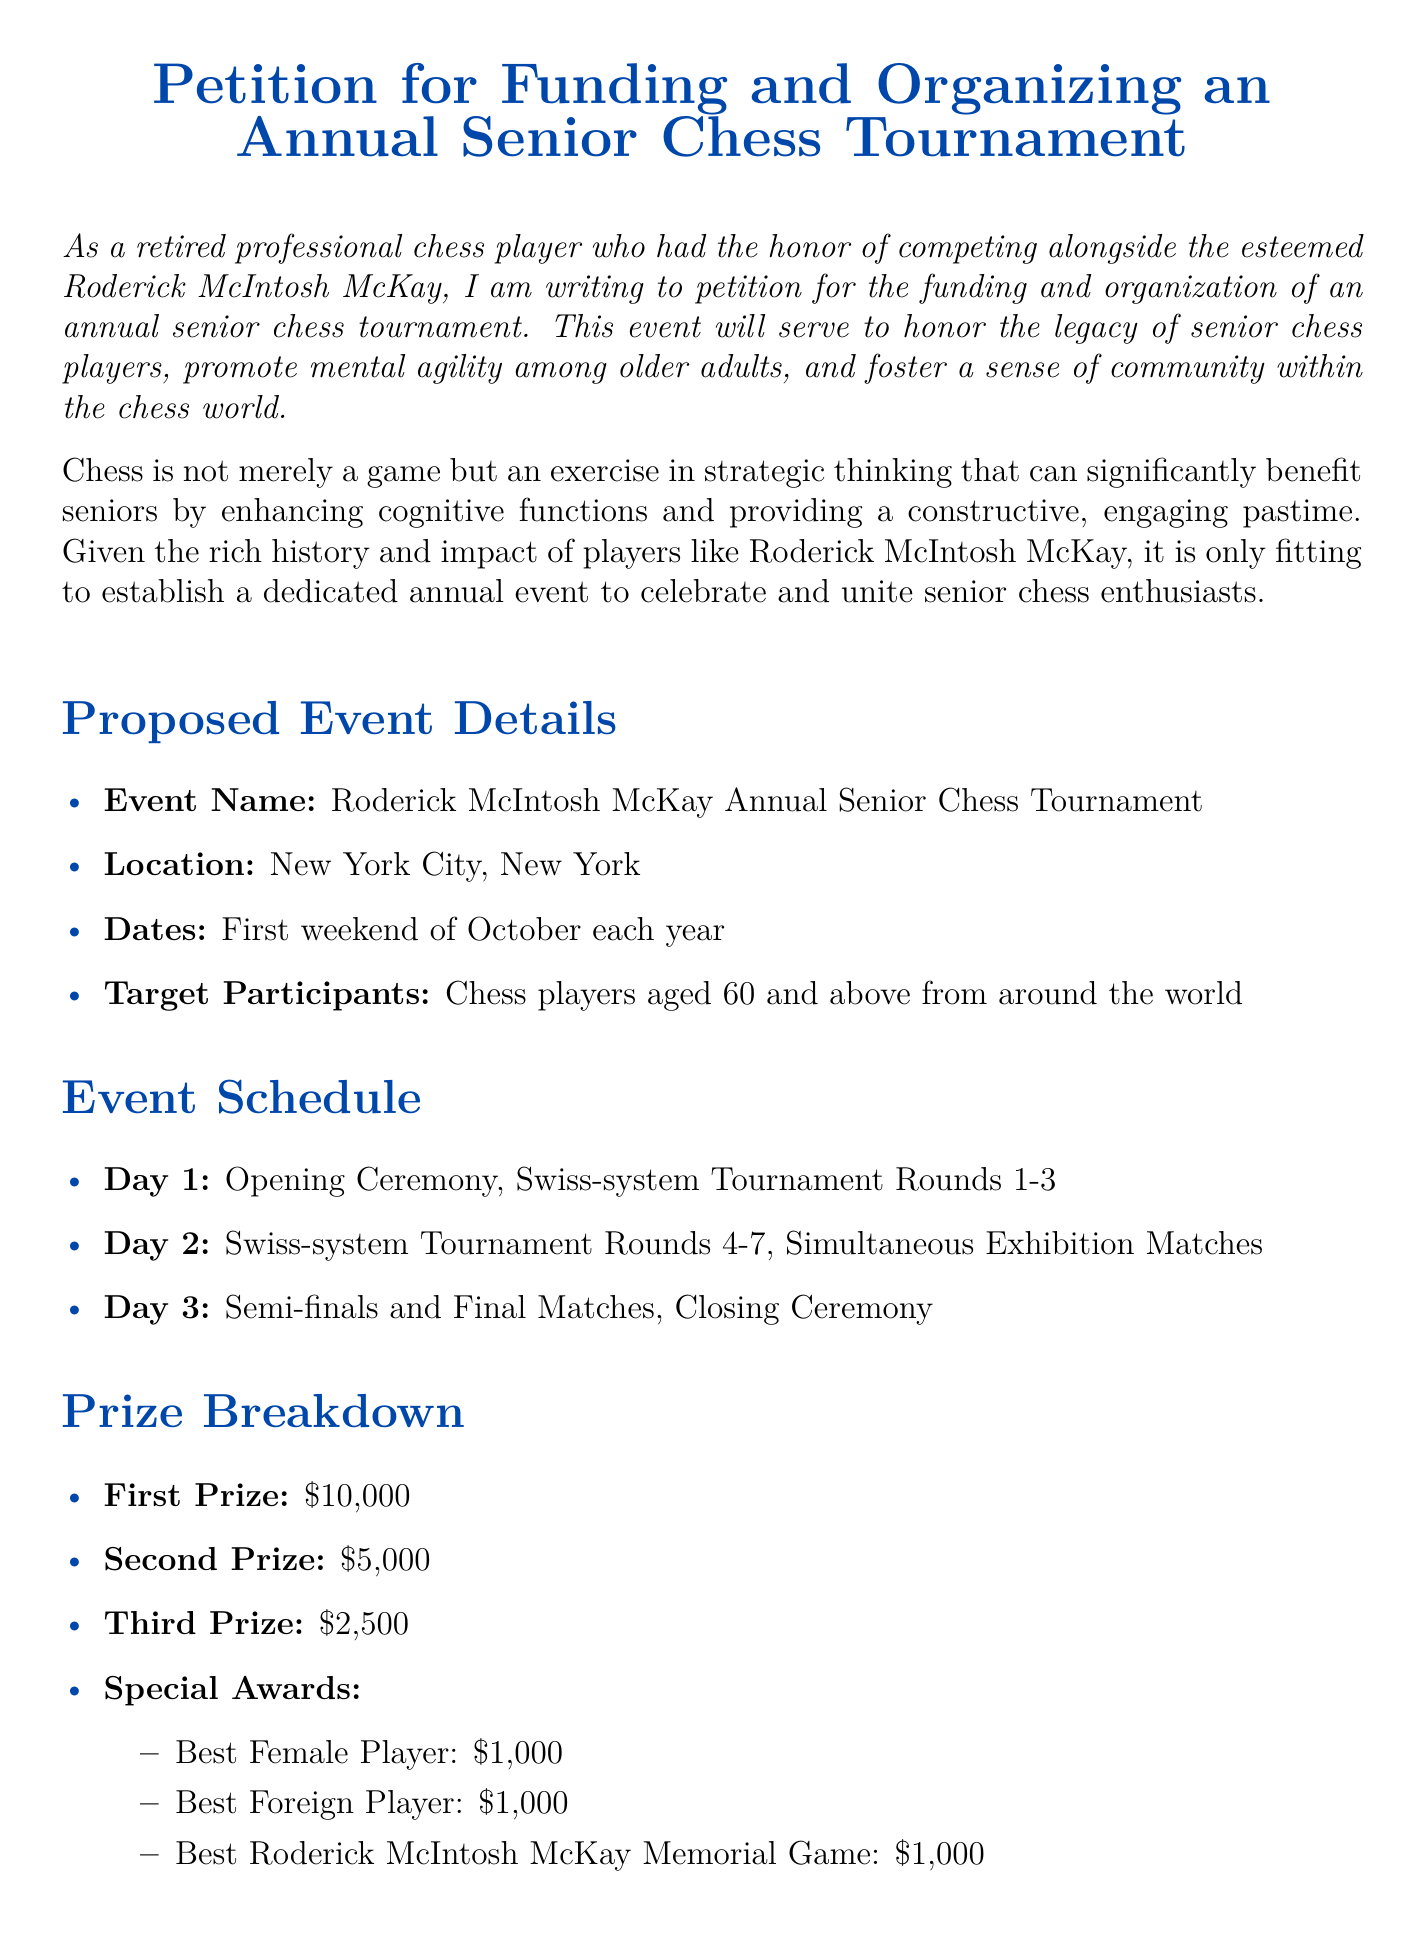What is the event name? The event name is mentioned in the proposed event details section.
Answer: Roderick McIntosh McKay Annual Senior Chess Tournament Where will the tournament be held? The location of the tournament is specified in the proposed event details section.
Answer: New York City, New York What is the total cost of the tournament? The total cost is provided in the budget estimate section.
Answer: $50,000 What is the prize for the first place winner? The first prize amount is listed in the prize breakdown section.
Answer: $10,000 When is the tournament scheduled to occur each year? The yearly occurrence of the tournament is indicated in the proposed event details section.
Answer: First weekend of October each year How many rounds are scheduled for Day 2? The number of rounds on Day 2 is detailed in the event schedule section.
Answer: 4-7 What special award has a $1,000 prize? The special awards are listed in the prize breakdown section, which includes multiple contenders for this prize amount.
Answer: Best Female Player What is included in the miscellaneous budget? The budget estimate section lists the miscellaneous cost but does not provide further detail, indicating it encompasses various smaller expenses.
Answer: $5,000 What type of tournament format will be used? The tournament format is specified in the event schedule section.
Answer: Swiss-system Tournament 